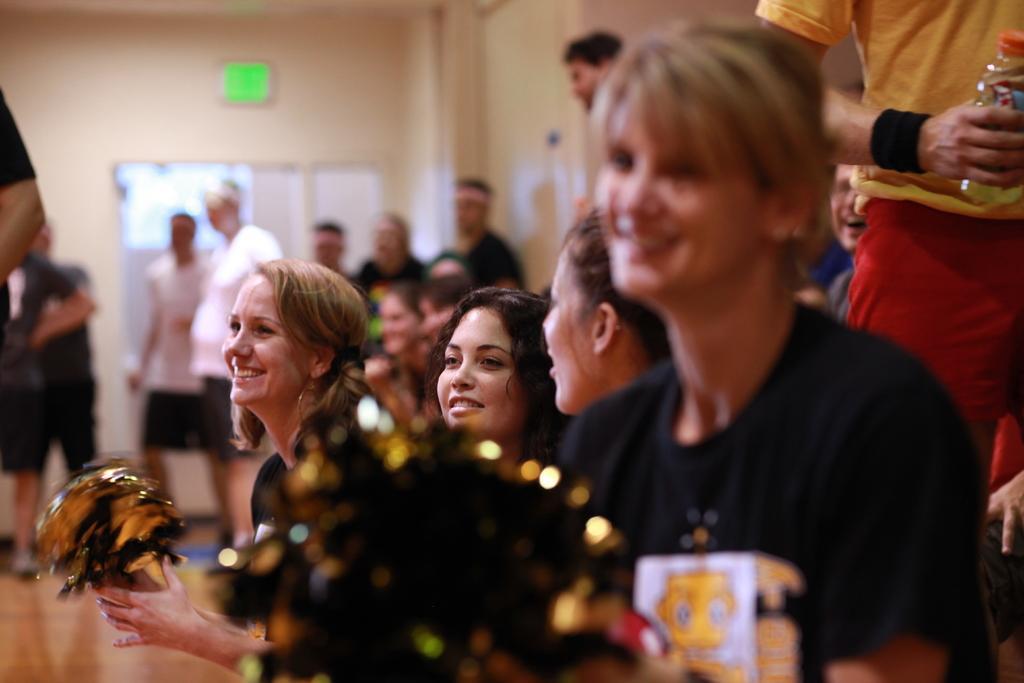Could you give a brief overview of what you see in this image? In this image we can see a few people, among them some people are holding the objects, in the background, we can see the wall, on the wall, there are some boards. 